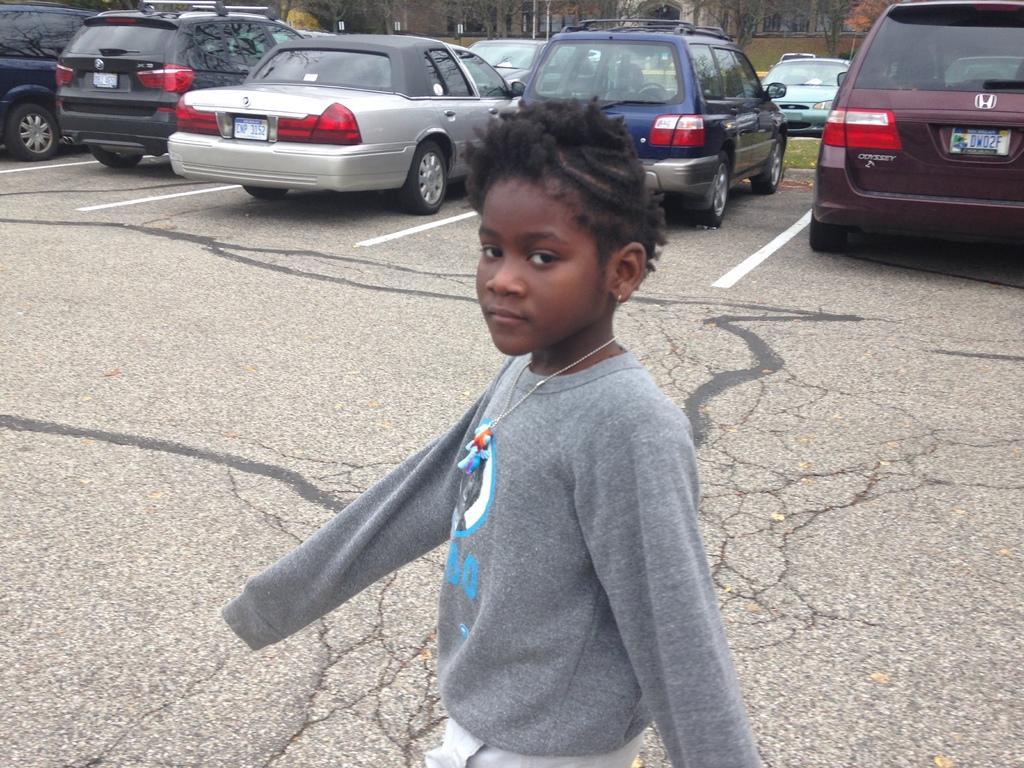Can you describe this image briefly? In this image we can see a kid wearing grey color sweatshirt walking on road and in the background of the image there are some vehicles which are parked on the road, there are some trees and some houses. 